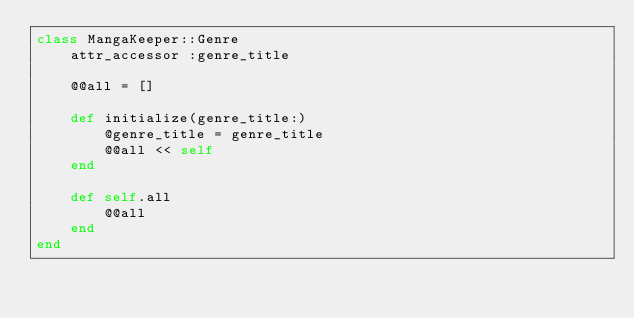<code> <loc_0><loc_0><loc_500><loc_500><_Ruby_>class MangaKeeper::Genre
    attr_accessor :genre_title

    @@all = []

    def initialize(genre_title:)
        @genre_title = genre_title
        @@all << self
    end

    def self.all
        @@all
    end
end</code> 